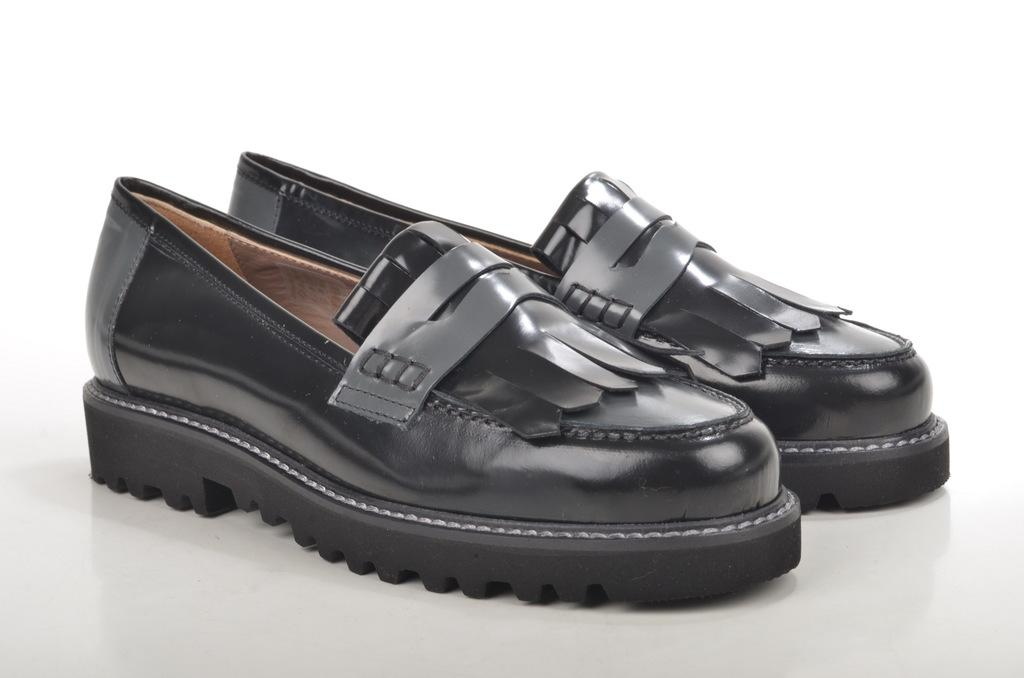What type of footwear is visible in the image? There is a pair of black shoes in the image. What is the color of the floor where the shoes are placed? The shoes are on a white floor. What type of cable can be seen connecting the shoes in the image? There is no cable connecting the shoes in the image; they are simply placed on the white floor. What type of beverage is being served in a glass next to the shoes in the image? There is no glass or beverage present in the image; it only features a pair of black shoes on a white floor. 